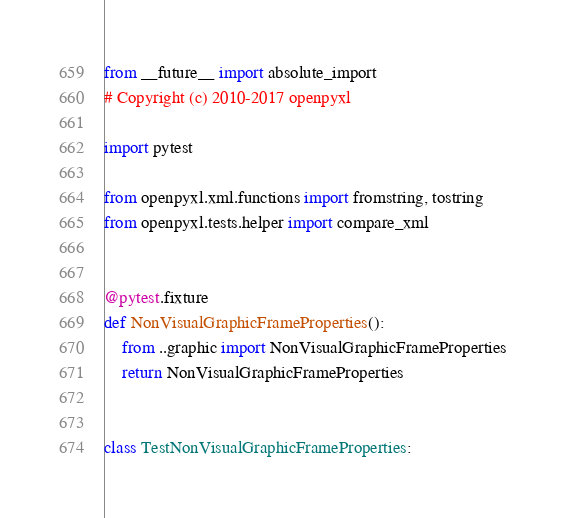Convert code to text. <code><loc_0><loc_0><loc_500><loc_500><_Python_>from __future__ import absolute_import
# Copyright (c) 2010-2017 openpyxl

import pytest

from openpyxl.xml.functions import fromstring, tostring
from openpyxl.tests.helper import compare_xml


@pytest.fixture
def NonVisualGraphicFrameProperties():
    from ..graphic import NonVisualGraphicFrameProperties
    return NonVisualGraphicFrameProperties


class TestNonVisualGraphicFrameProperties:
</code> 